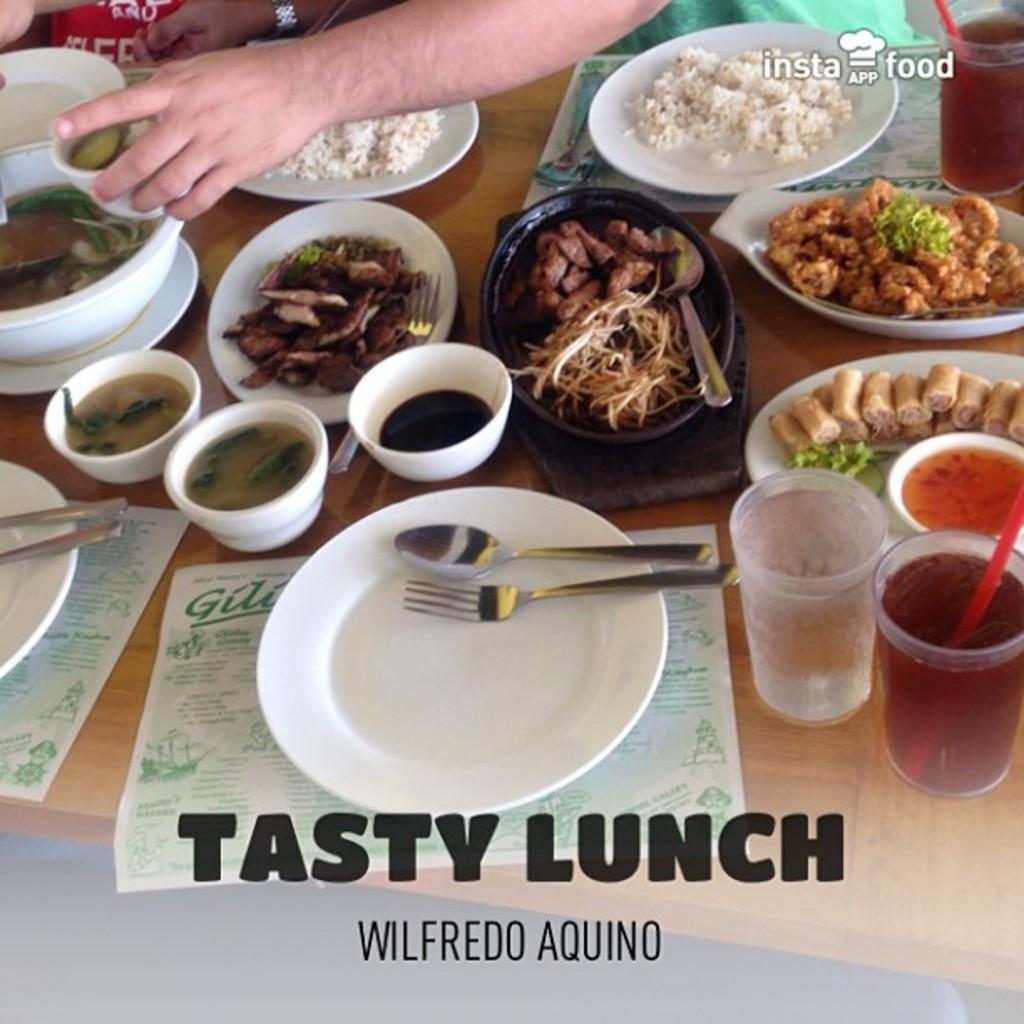Could you give a brief overview of what you see in this image? As we can see in the image there is a person and table. On table there are bowls, plates, fork, spoon, glasses and different types of dishes. 